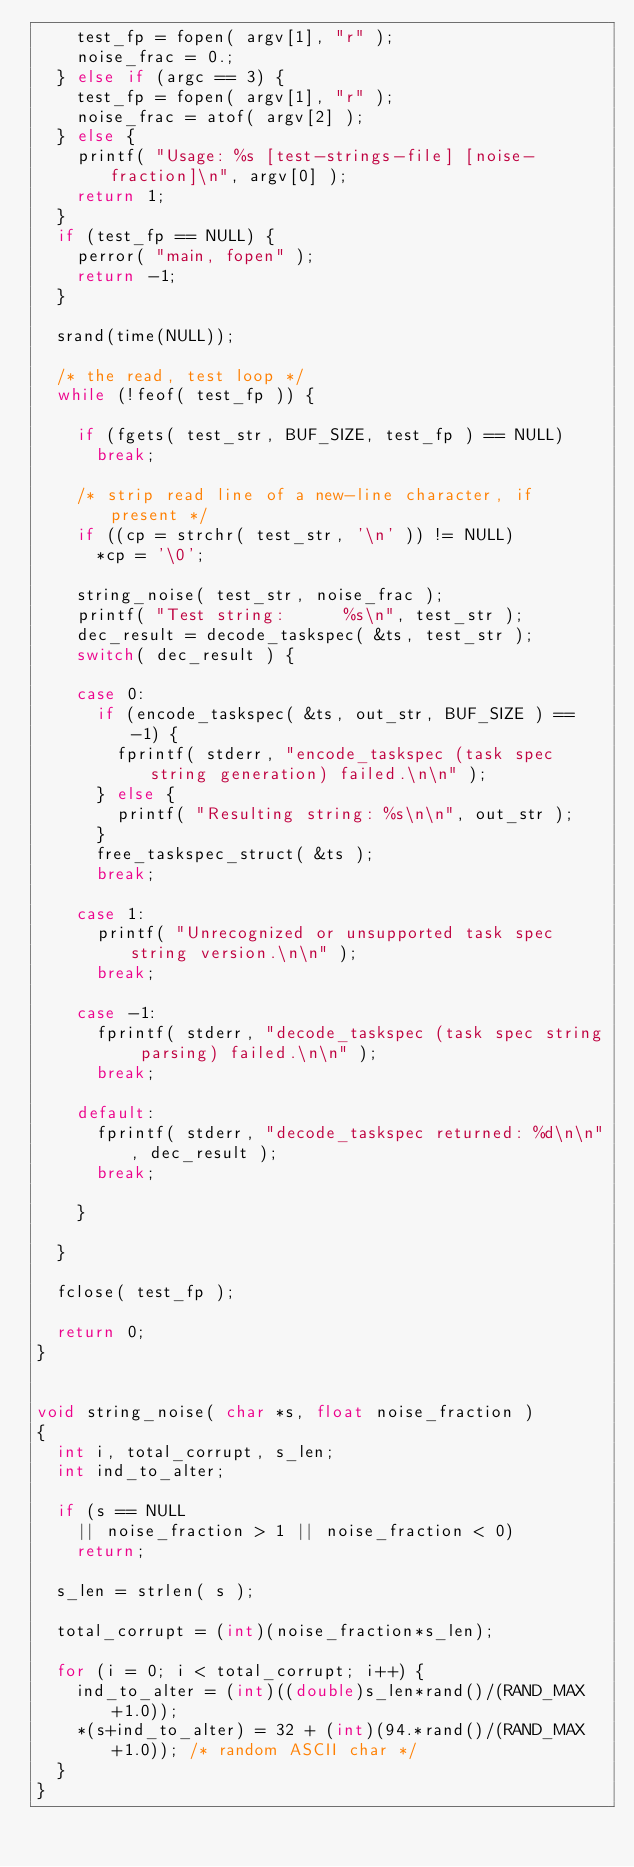<code> <loc_0><loc_0><loc_500><loc_500><_C_>		test_fp = fopen( argv[1], "r" );
		noise_frac = 0.;
	} else if (argc == 3) {
		test_fp = fopen( argv[1], "r" );
		noise_frac = atof( argv[2] );
	} else {
		printf( "Usage: %s [test-strings-file] [noise-fraction]\n", argv[0] );
		return 1;
	}
	if (test_fp == NULL) {
		perror( "main, fopen" );
		return -1;
	}

	srand(time(NULL));

	/* the read, test loop */
	while (!feof( test_fp )) {

		if (fgets( test_str, BUF_SIZE, test_fp ) == NULL)
			break;

		/* strip read line of a new-line character, if present */
		if ((cp = strchr( test_str, '\n' )) != NULL)
			*cp = '\0';

		string_noise( test_str, noise_frac );
		printf( "Test string:      %s\n", test_str );
		dec_result = decode_taskspec( &ts, test_str );
		switch( dec_result ) {

		case 0:
			if (encode_taskspec( &ts, out_str, BUF_SIZE ) == -1) {
				fprintf( stderr, "encode_taskspec (task spec string generation) failed.\n\n" );
			} else {
				printf( "Resulting string: %s\n\n", out_str );
			}
			free_taskspec_struct( &ts );
			break;

		case 1:
			printf( "Unrecognized or unsupported task spec string version.\n\n" );
			break;

		case -1:
			fprintf( stderr, "decode_taskspec (task spec string parsing) failed.\n\n" );
			break;

		default:
			fprintf( stderr, "decode_taskspec returned: %d\n\n", dec_result );
			break;

		}

	}

	fclose( test_fp );

	return 0;
}


void string_noise( char *s, float noise_fraction )
{
	int i, total_corrupt, s_len;
	int ind_to_alter;

	if (s == NULL
		|| noise_fraction > 1 || noise_fraction < 0)
		return;

	s_len = strlen( s );

	total_corrupt = (int)(noise_fraction*s_len);

	for (i = 0; i < total_corrupt; i++) {
		ind_to_alter = (int)((double)s_len*rand()/(RAND_MAX+1.0));
		*(s+ind_to_alter) = 32 + (int)(94.*rand()/(RAND_MAX+1.0)); /* random ASCII char */
	}
}
</code> 